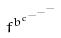Convert formula to latex. <formula><loc_0><loc_0><loc_500><loc_500>f ^ { b ^ { c ^ { - ^ { - ^ { - } } } } }</formula> 